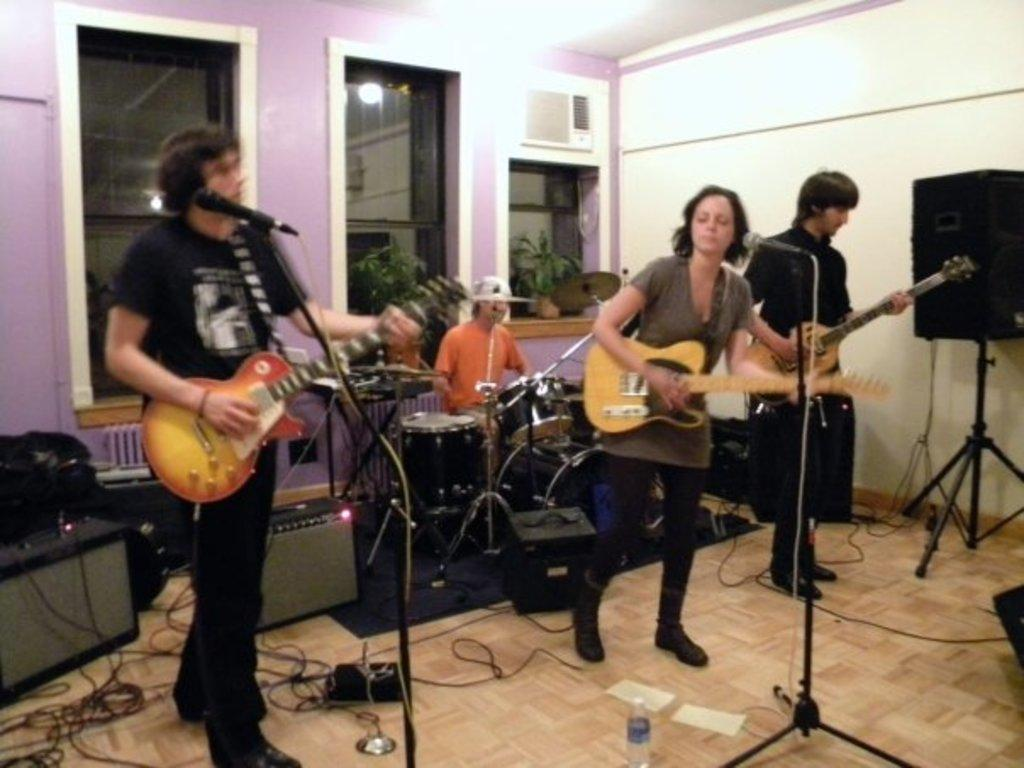What is happening in the image? There is a group of people in the image, and they are playing musical instruments. What type of activity are the people engaged in? The people are playing musical instruments, which suggests they might be performing or practicing music. What type of meal is being shared among the group in the image? There is no meal present in the image; the group of people are playing musical instruments. Can you see a dog playing with the group in the image? There is no dog present in the image; the group of people are playing musical instruments. 